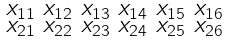Convert formula to latex. <formula><loc_0><loc_0><loc_500><loc_500>\begin{smallmatrix} x _ { 1 1 } & x _ { 1 2 } & x _ { 1 3 } & x _ { 1 4 } & x _ { 1 5 } & x _ { 1 6 } \\ x _ { 2 1 } & x _ { 2 2 } & x _ { 2 3 } & x _ { 2 4 } & x _ { 2 5 } & x _ { 2 6 } \end{smallmatrix}</formula> 